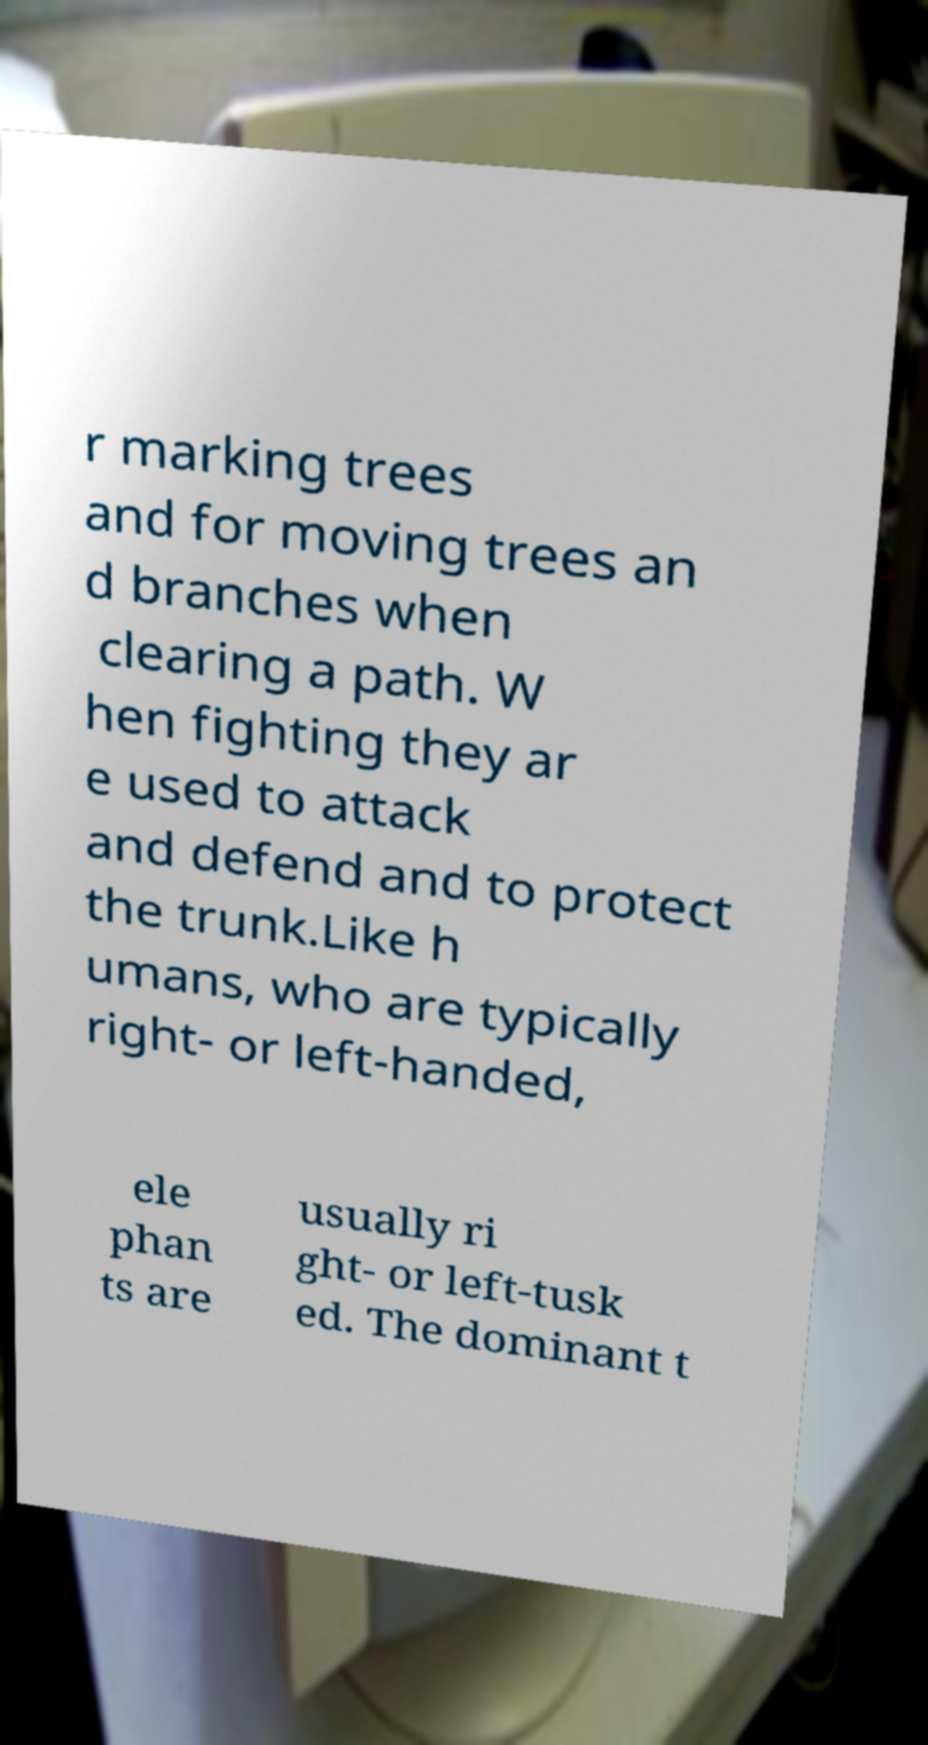Could you extract and type out the text from this image? r marking trees and for moving trees an d branches when clearing a path. W hen fighting they ar e used to attack and defend and to protect the trunk.Like h umans, who are typically right- or left-handed, ele phan ts are usually ri ght- or left-tusk ed. The dominant t 